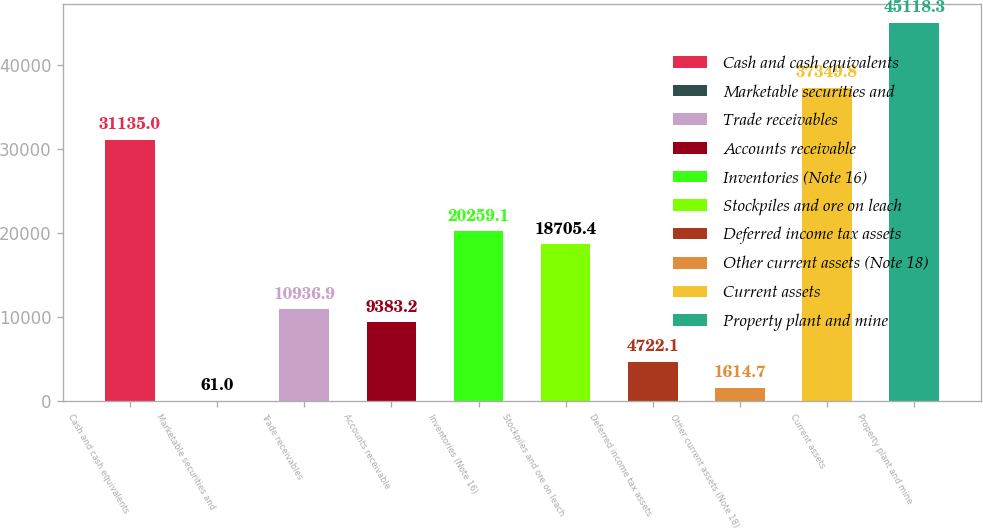Convert chart to OTSL. <chart><loc_0><loc_0><loc_500><loc_500><bar_chart><fcel>Cash and cash equivalents<fcel>Marketable securities and<fcel>Trade receivables<fcel>Accounts receivable<fcel>Inventories (Note 16)<fcel>Stockpiles and ore on leach<fcel>Deferred income tax assets<fcel>Other current assets (Note 18)<fcel>Current assets<fcel>Property plant and mine<nl><fcel>31135<fcel>61<fcel>10936.9<fcel>9383.2<fcel>20259.1<fcel>18705.4<fcel>4722.1<fcel>1614.7<fcel>37349.8<fcel>45118.3<nl></chart> 